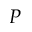Convert formula to latex. <formula><loc_0><loc_0><loc_500><loc_500>P</formula> 